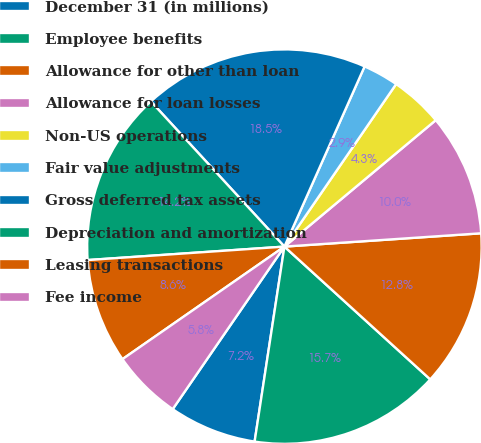Convert chart. <chart><loc_0><loc_0><loc_500><loc_500><pie_chart><fcel>December 31 (in millions)<fcel>Employee benefits<fcel>Allowance for other than loan<fcel>Allowance for loan losses<fcel>Non-US operations<fcel>Fair value adjustments<fcel>Gross deferred tax assets<fcel>Depreciation and amortization<fcel>Leasing transactions<fcel>Fee income<nl><fcel>7.17%<fcel>15.66%<fcel>12.83%<fcel>10.0%<fcel>4.34%<fcel>2.92%<fcel>18.5%<fcel>14.25%<fcel>8.58%<fcel>5.75%<nl></chart> 